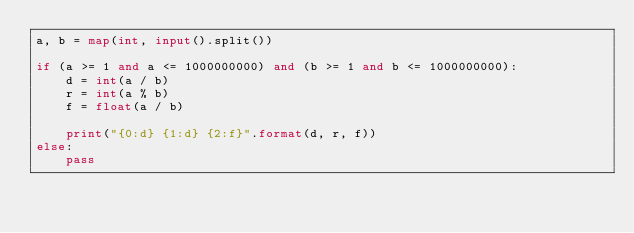Convert code to text. <code><loc_0><loc_0><loc_500><loc_500><_Python_>a, b = map(int, input().split())

if (a >= 1 and a <= 1000000000) and (b >= 1 and b <= 1000000000):
    d = int(a / b)
    r = int(a % b)
    f = float(a / b)

    print("{0:d} {1:d} {2:f}".format(d, r, f))
else:
    pass</code> 